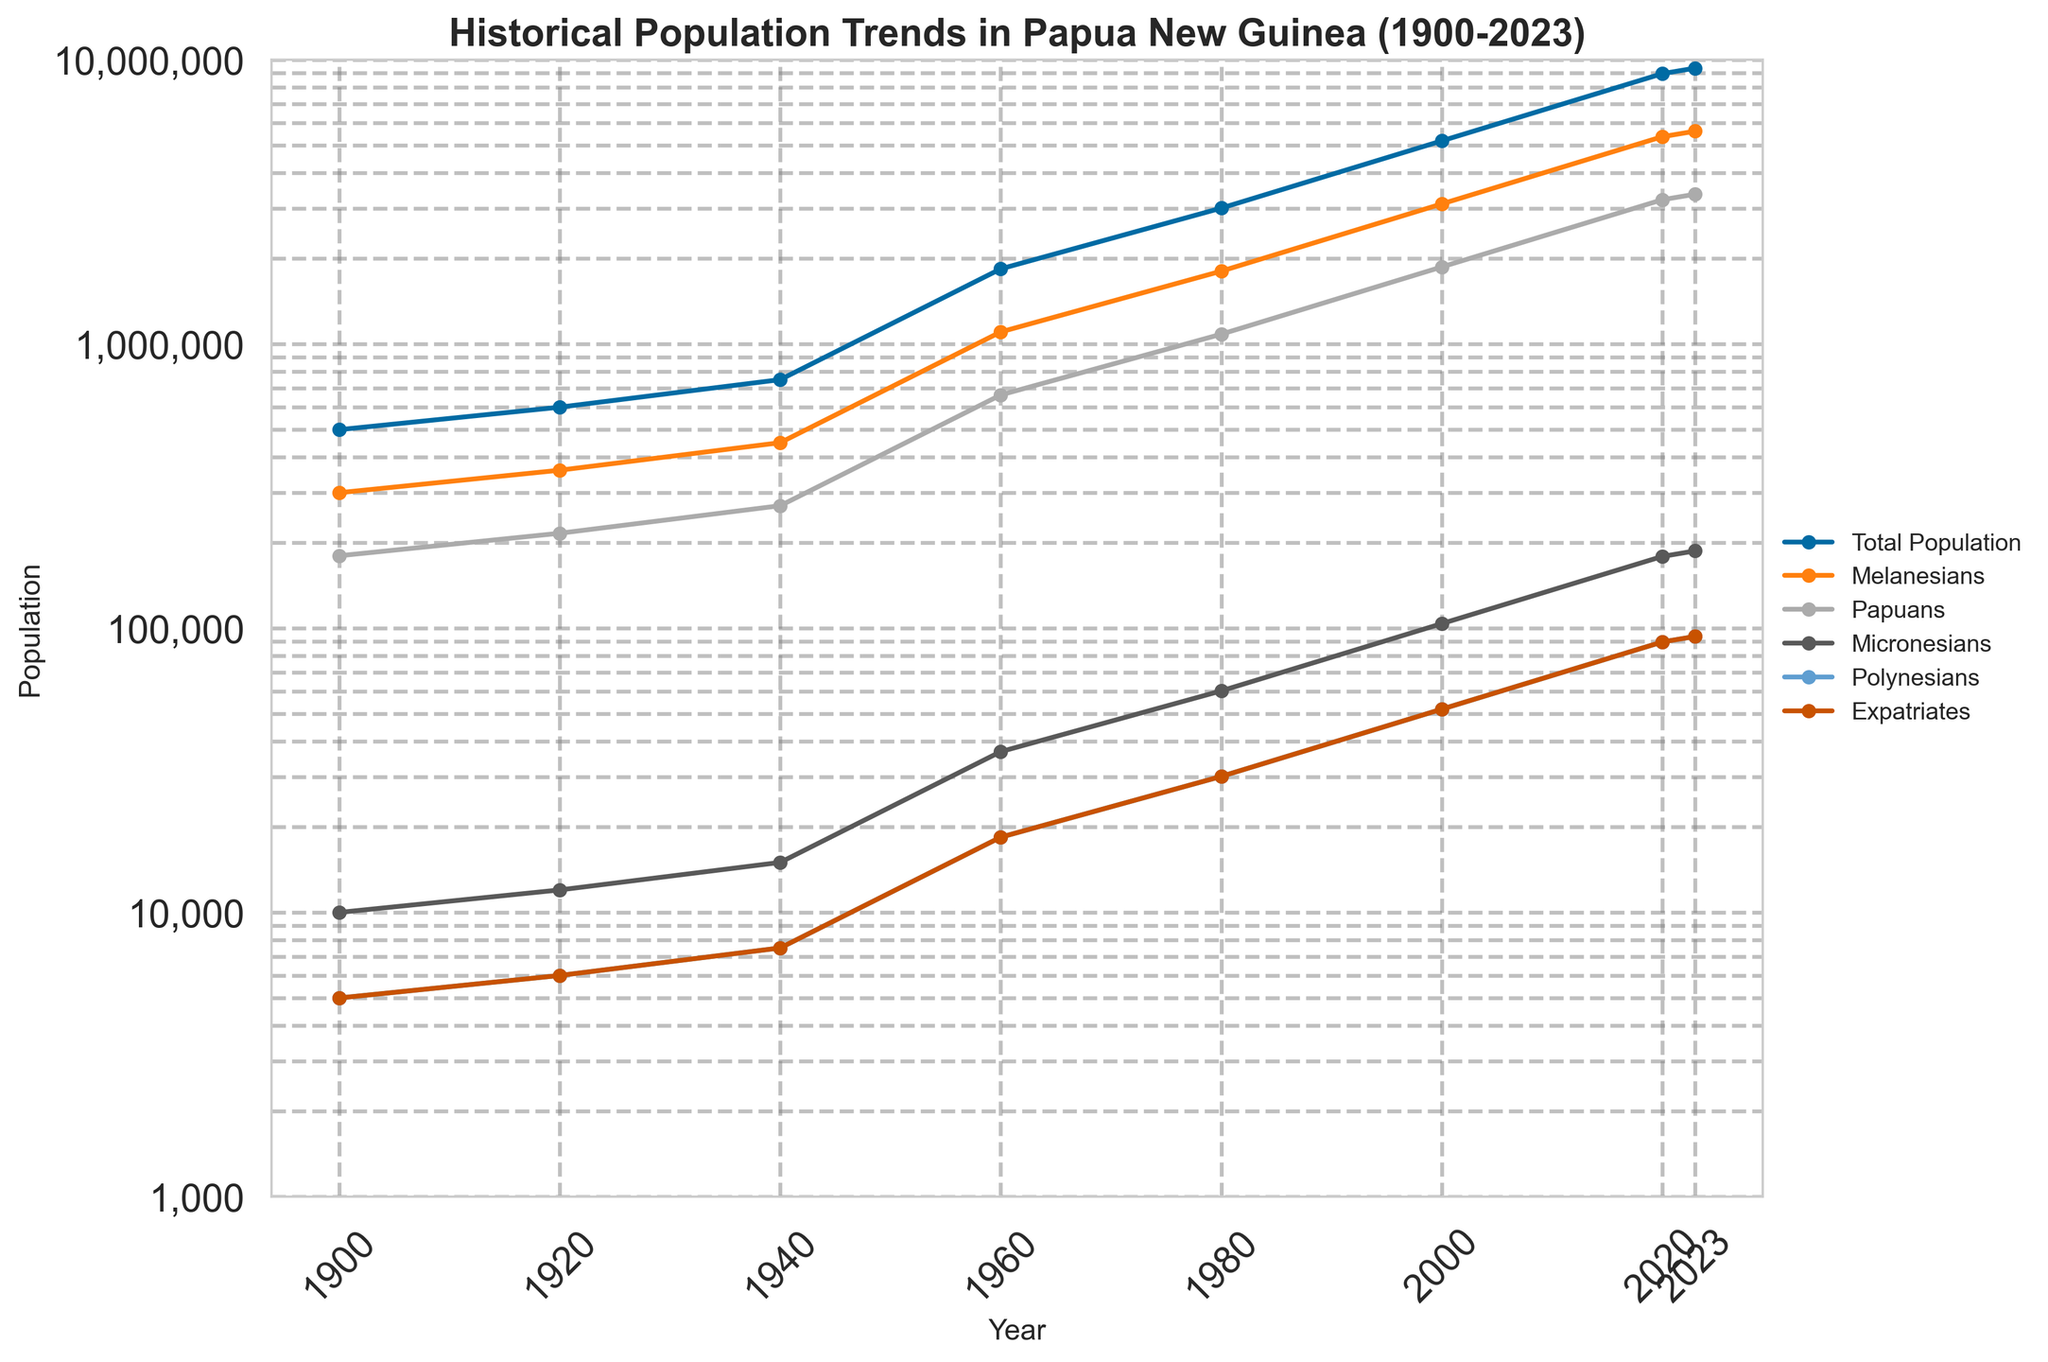What was the total population of Papua New Guinea in 1960? The figure shows the population trends from 1900 to 2023. Look for the data point corresponding to the year 1960 and read the total population value from the "Total Population" line.
Answer: 1,840,000 Which ethnic group had the largest growth between 1900 and 2020? Observe the trend lines for each ethnic group from 1900 to 2020. Compare the population values at these two points in time and determine which group had the largest increase.
Answer: Melanesians How many more Melanesians were there than Papuans in 1940? Look at the population values for Melanesians and Papuans in 1940 on the figure. Subtract the number of Papuans from the number of Melanesians.
Answer: 180,000 Which year showed the first major spike in total population growth? Analyze the curve representing the Total Population. Identify the first year where the rate of increase in population noticeably accelerates.
Answer: 1960 What is the average population of Micronesians across the entire period? Add the population figures for Micronesians from each year displayed and divide by the number of data points (8 years in total).
Answer: (10,000 + 12,000 + 15,000 + 36,800 + 60,200 + 103,800 + 178,940 + 187,200) / 8 = 75,740 Was the population of expatriates in 2000 higher or lower than in 1980? Compare the value of the Expatriates population line between the years 1980 and 2000.
Answer: Higher Which ethnic group had the smallest population in 2023? Look at the data values for the year 2023 and identify the group with the lowest population value from the ethnic groups listed.
Answer: Polynesians What visual indication shows that the population scale is logarithmic? Notice that the spacing between population values on the Y-axis is inconsistent: each step gets exponentially larger, indicating a logarithmic scale.
Answer: Logarithmic spacing of Y-axis Compare the population increase of Papuans between 1960 and 1980, and between 2000 and 2020. Which period saw a greater increase? Calculate the difference in Papuans' population between 1960-1980 and 2000-2020 by subtracting the populations at the start and end of each period. Compare these increases.
Answer: 1960-1980: 1,083,600 - 662,400 = 421,200; 2000-2020: 3,220,920 - 1,868,400 = 1,352,520; Greater increase from 2000-2020 